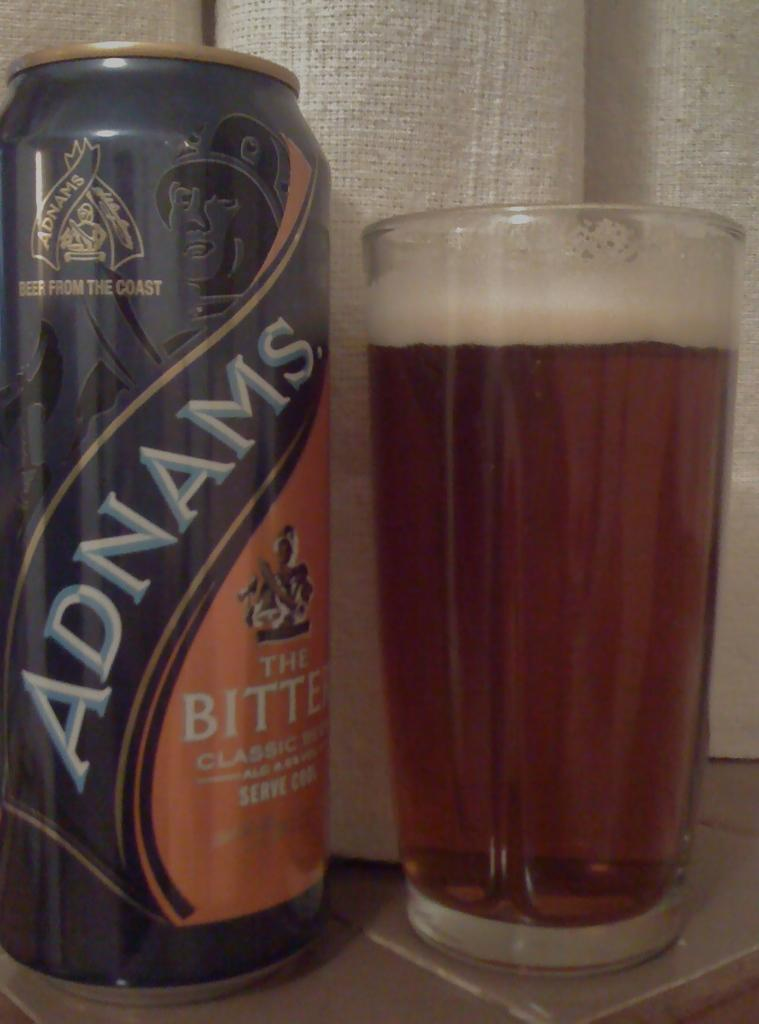<image>
Present a compact description of the photo's key features. A bottle of Adnams bitter beer has been poured into a glass 